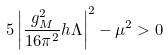<formula> <loc_0><loc_0><loc_500><loc_500>5 \left | \frac { g _ { M } ^ { 2 } } { 1 6 \pi ^ { 2 } } h \Lambda \right | ^ { 2 } - \mu ^ { 2 } > 0</formula> 